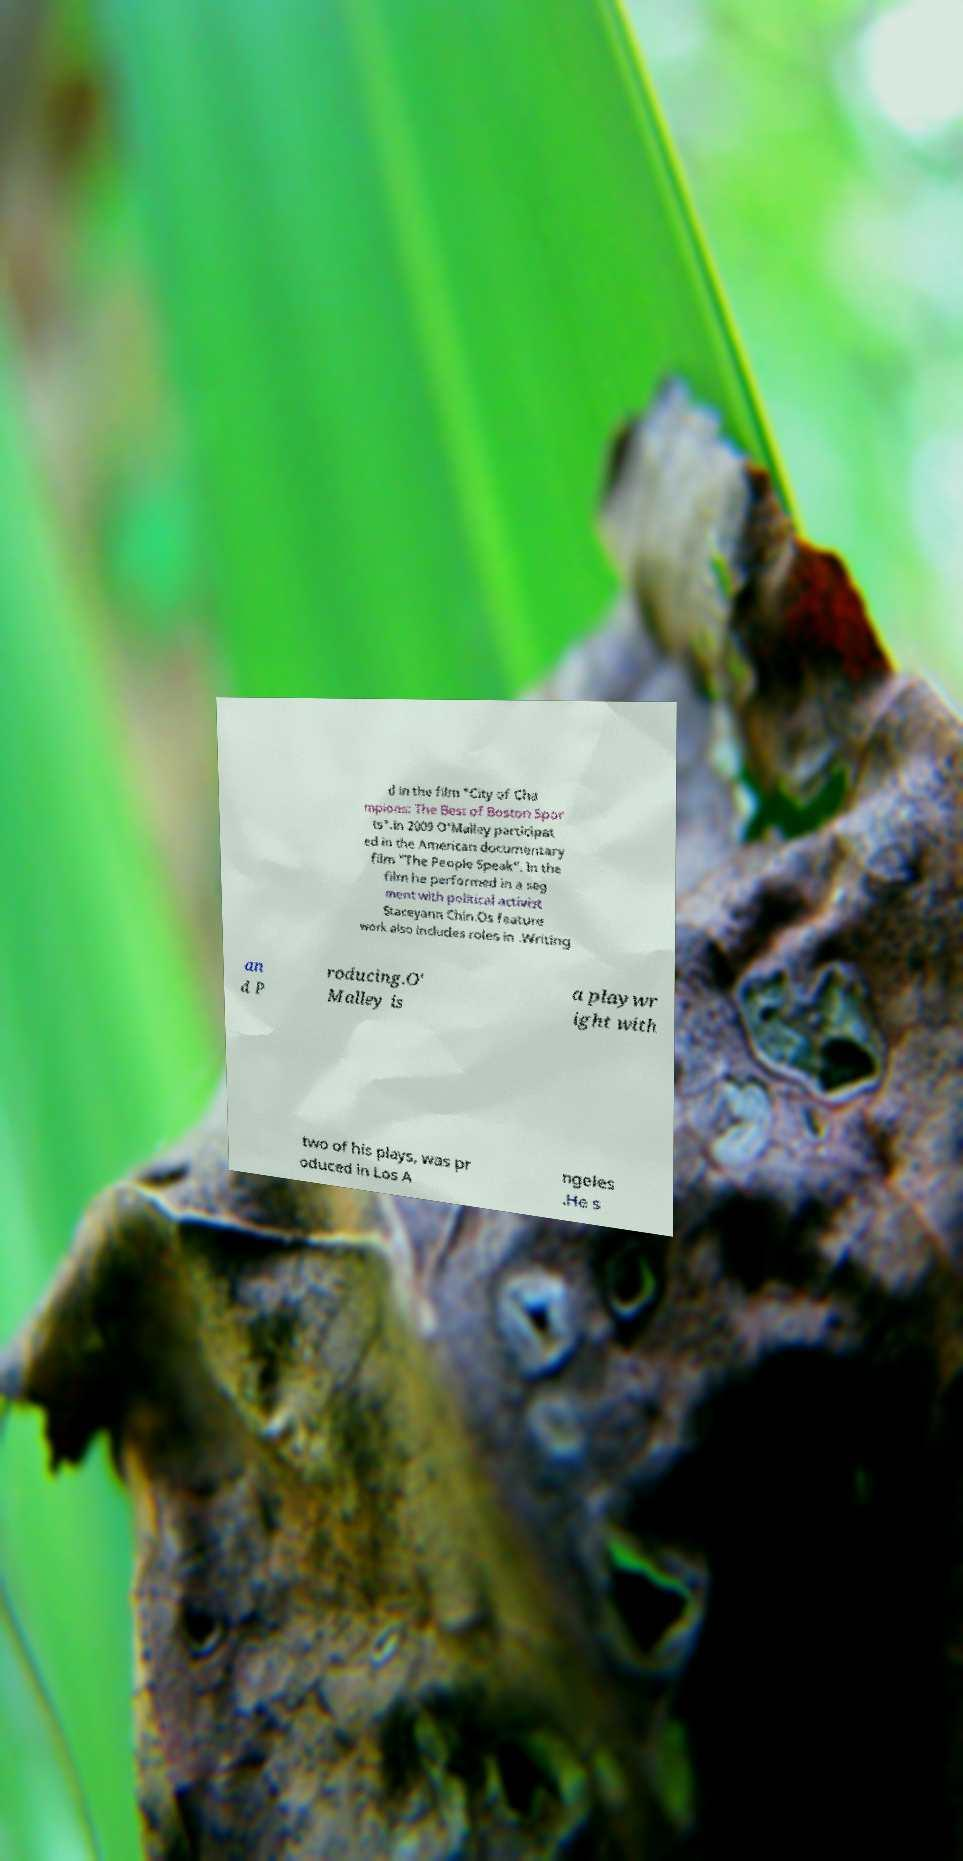Could you extract and type out the text from this image? d in the film "City of Cha mpions: The Best of Boston Spor ts".In 2009 O'Malley participat ed in the American documentary film "The People Speak". In the film he performed in a seg ment with political activist Staceyann Chin.Os feature work also includes roles in .Writing an d P roducing.O' Malley is a playwr ight with two of his plays, was pr oduced in Los A ngeles .He s 